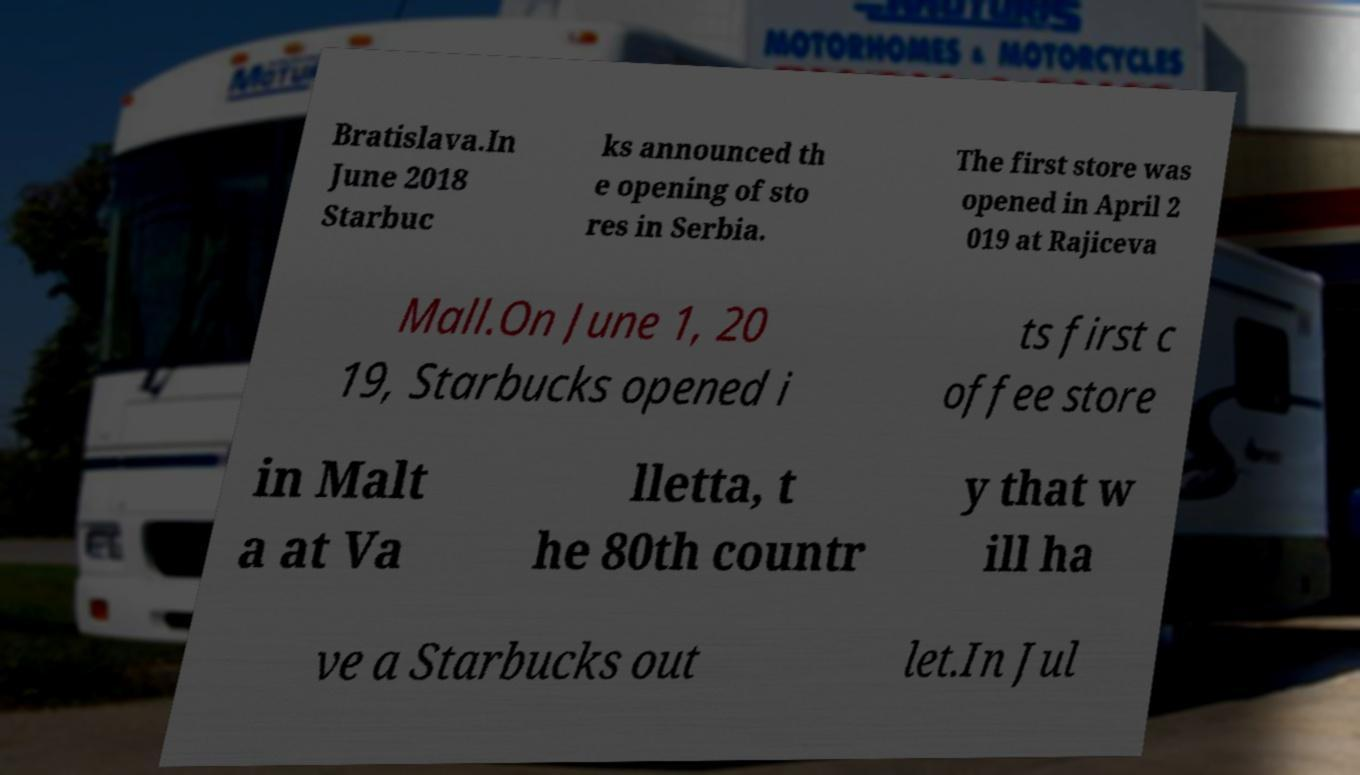I need the written content from this picture converted into text. Can you do that? Bratislava.In June 2018 Starbuc ks announced th e opening of sto res in Serbia. The first store was opened in April 2 019 at Rajiceva Mall.On June 1, 20 19, Starbucks opened i ts first c offee store in Malt a at Va lletta, t he 80th countr y that w ill ha ve a Starbucks out let.In Jul 